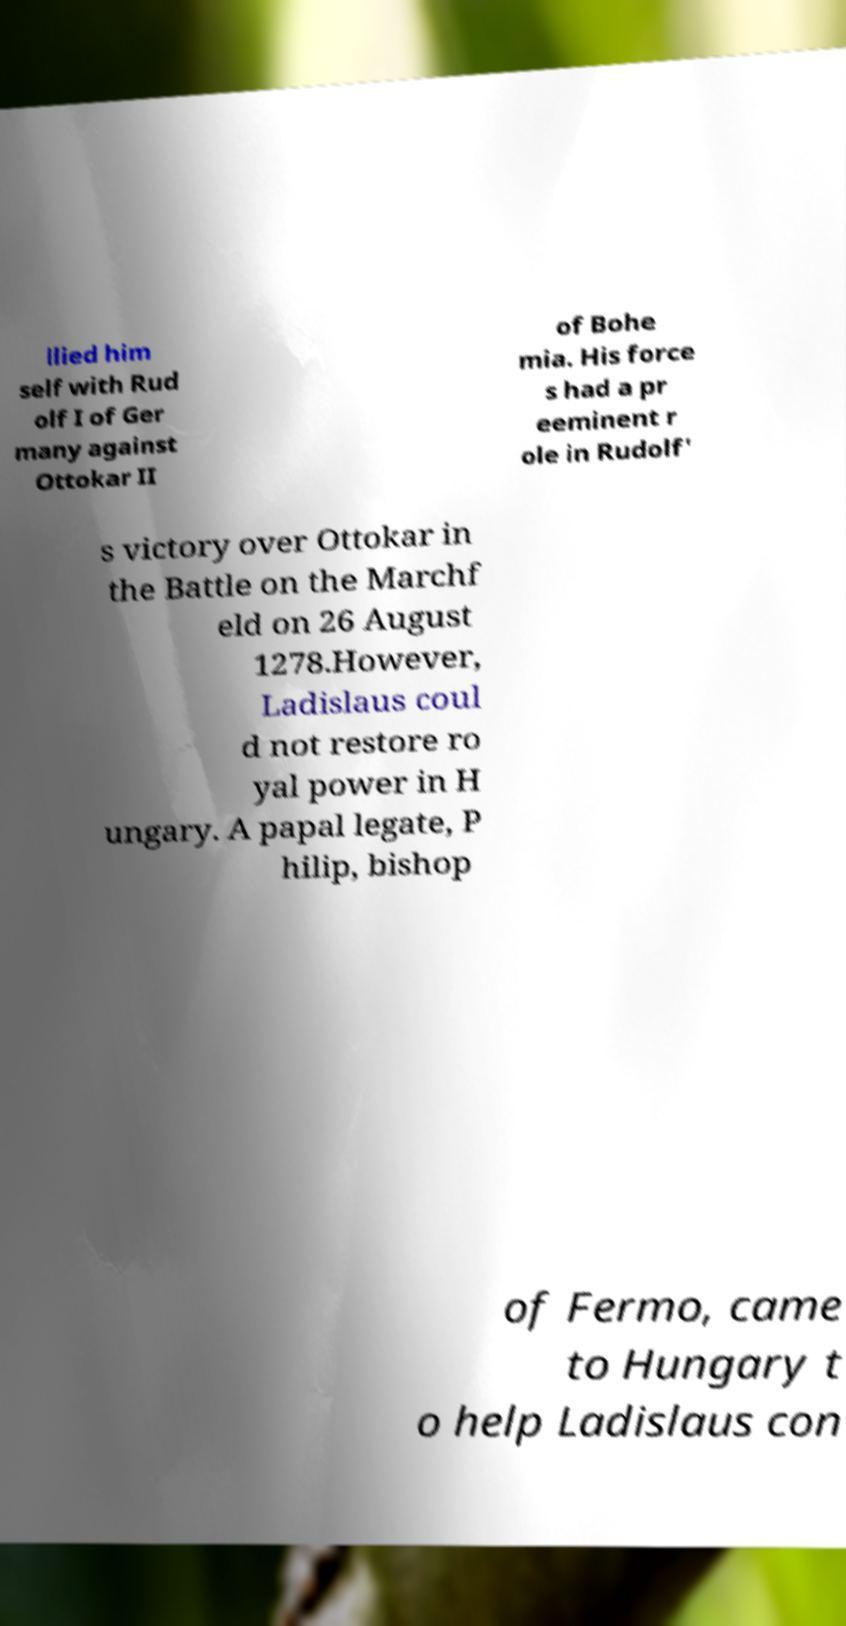There's text embedded in this image that I need extracted. Can you transcribe it verbatim? llied him self with Rud olf I of Ger many against Ottokar II of Bohe mia. His force s had a pr eeminent r ole in Rudolf' s victory over Ottokar in the Battle on the Marchf eld on 26 August 1278.However, Ladislaus coul d not restore ro yal power in H ungary. A papal legate, P hilip, bishop of Fermo, came to Hungary t o help Ladislaus con 